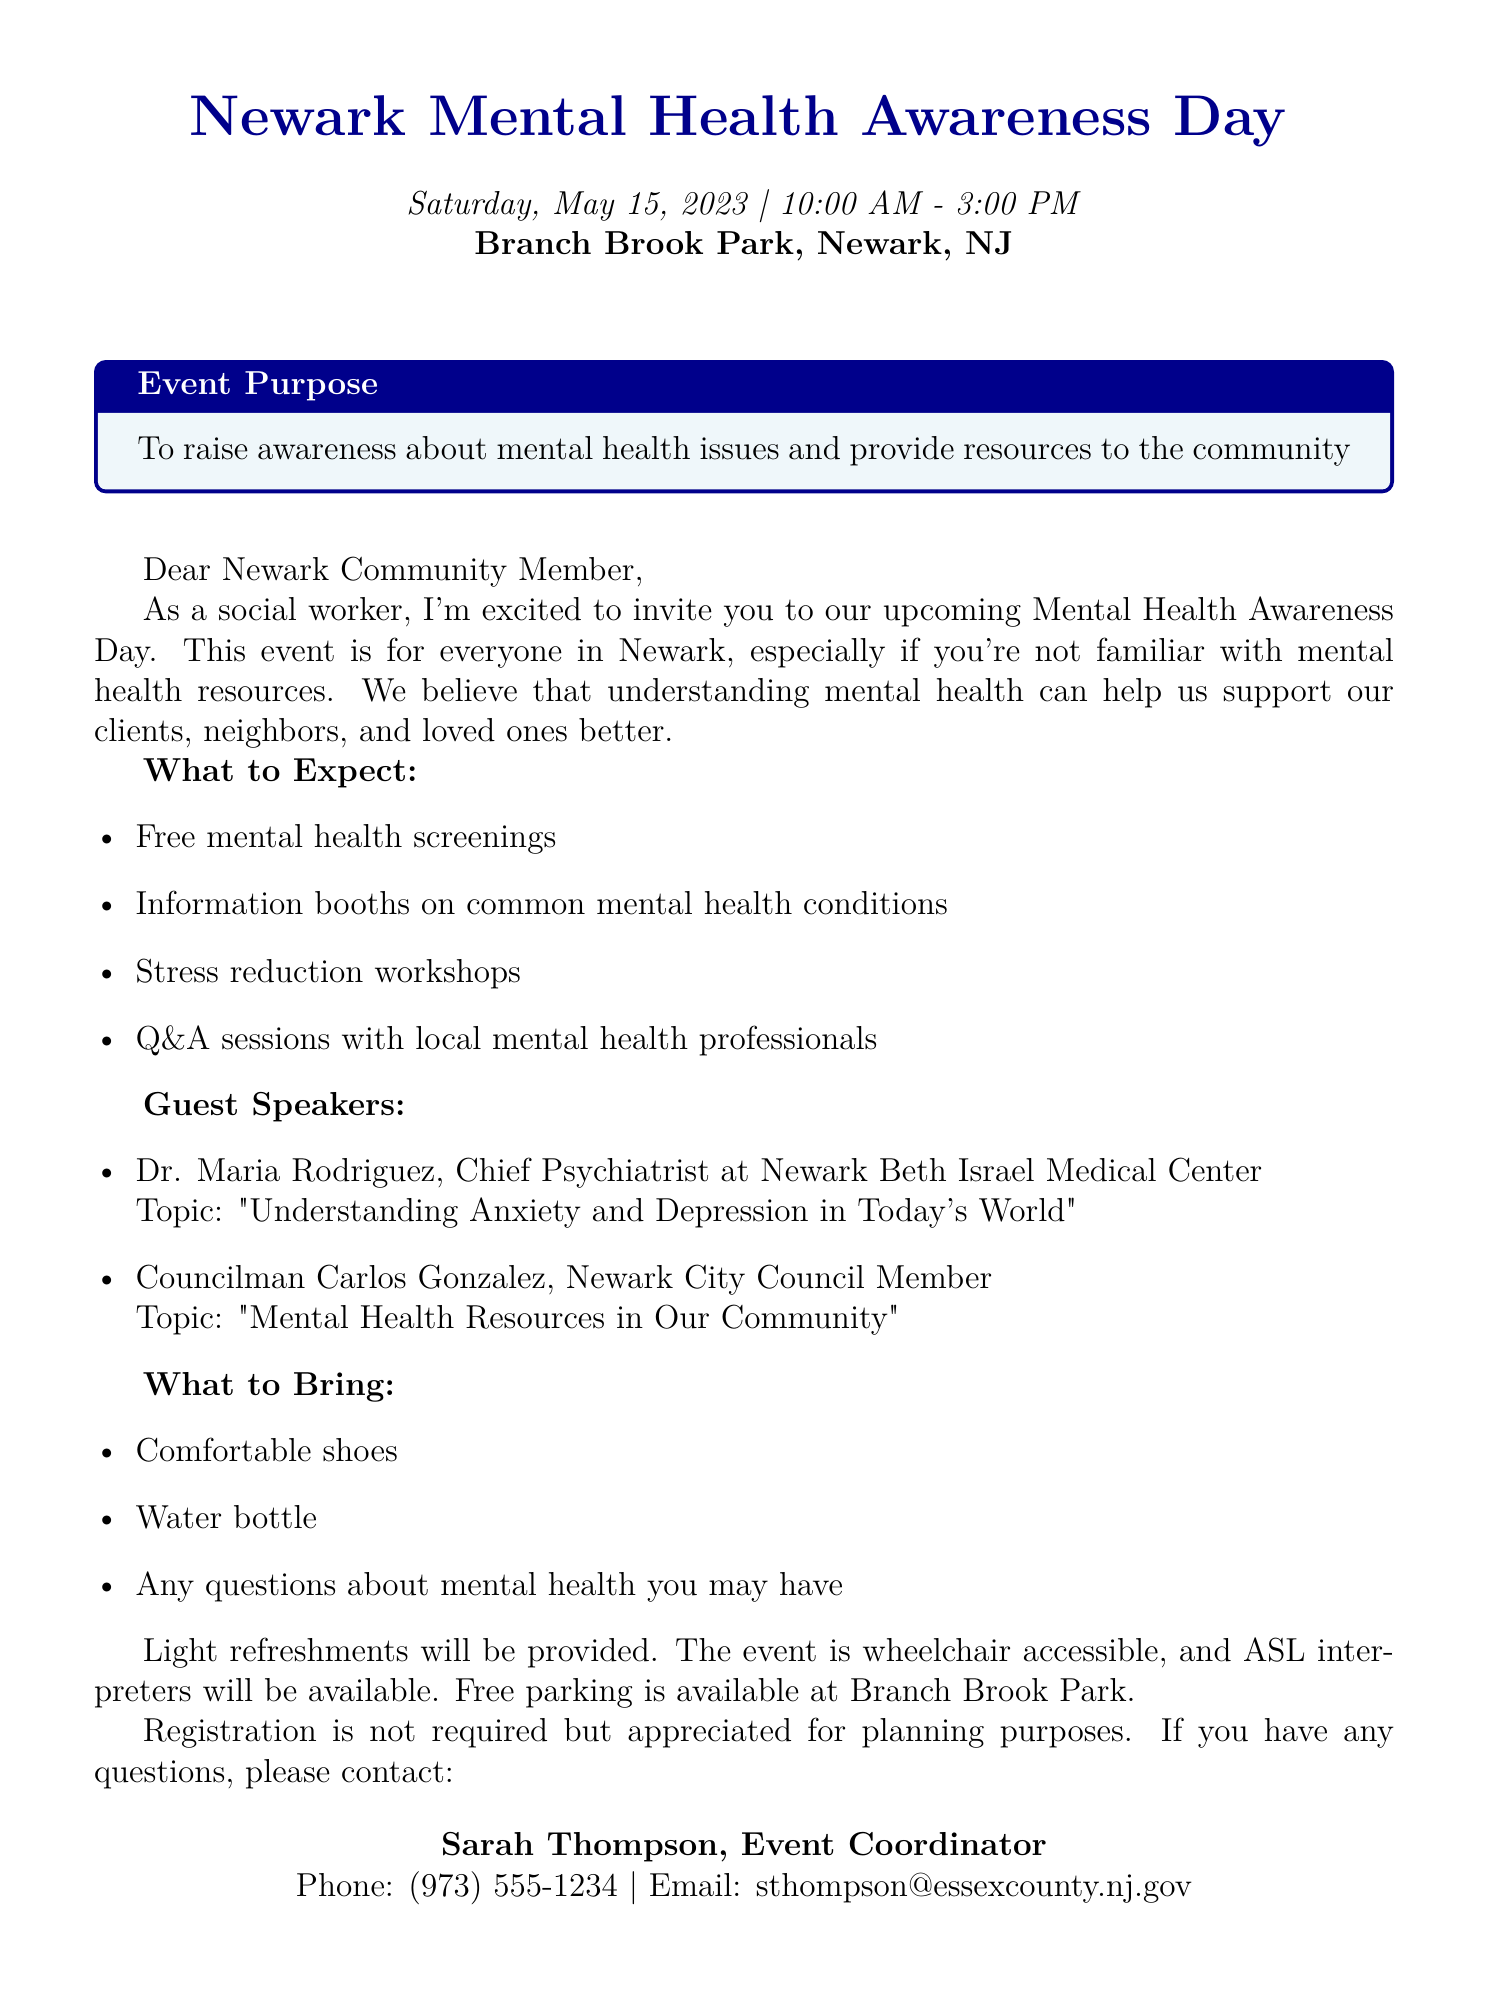What is the event name? The event name is explicitly stated in the document.
Answer: Newark Mental Health Awareness Day What is the date of the event? The date is provided in the document.
Answer: Saturday, May 15, 2023 What time does the event start? The starting time of the event is mentioned in the document.
Answer: 10:00 AM Who is the event coordinator? The event coordinator's name and title are given in the document.
Answer: Sarah Thompson What activities are included in the event? The document lists different activities planned for the event.
Answer: Free mental health screenings, informational booths on common mental health conditions, stress reduction workshops, Q&A sessions with local mental health professionals How long is the event scheduled to last? The duration of the event is indicated by the start and end times.
Answer: 5 hours Is registration required? The document states whether registration is mandatory or optional.
Answer: Not required What should participants bring? The document specifies items that participants are encouraged to bring.
Answer: Comfortable shoes, water bottle, any questions about mental health you may have How is the event accessible? The document describes the accessibility features of the event.
Answer: Wheelchair accessible and ASL interpreters will be available 